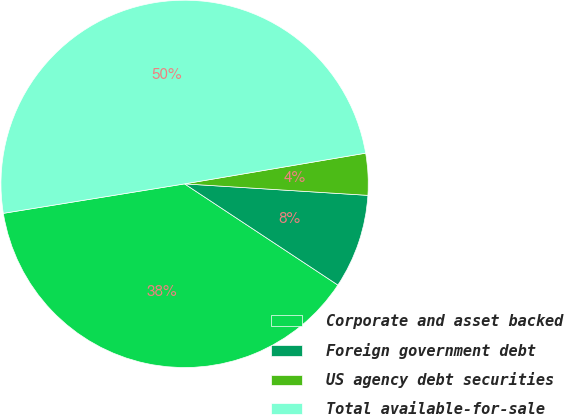Convert chart. <chart><loc_0><loc_0><loc_500><loc_500><pie_chart><fcel>Corporate and asset backed<fcel>Foreign government debt<fcel>US agency debt securities<fcel>Total available-for-sale<nl><fcel>38.15%<fcel>8.29%<fcel>3.67%<fcel>49.89%<nl></chart> 